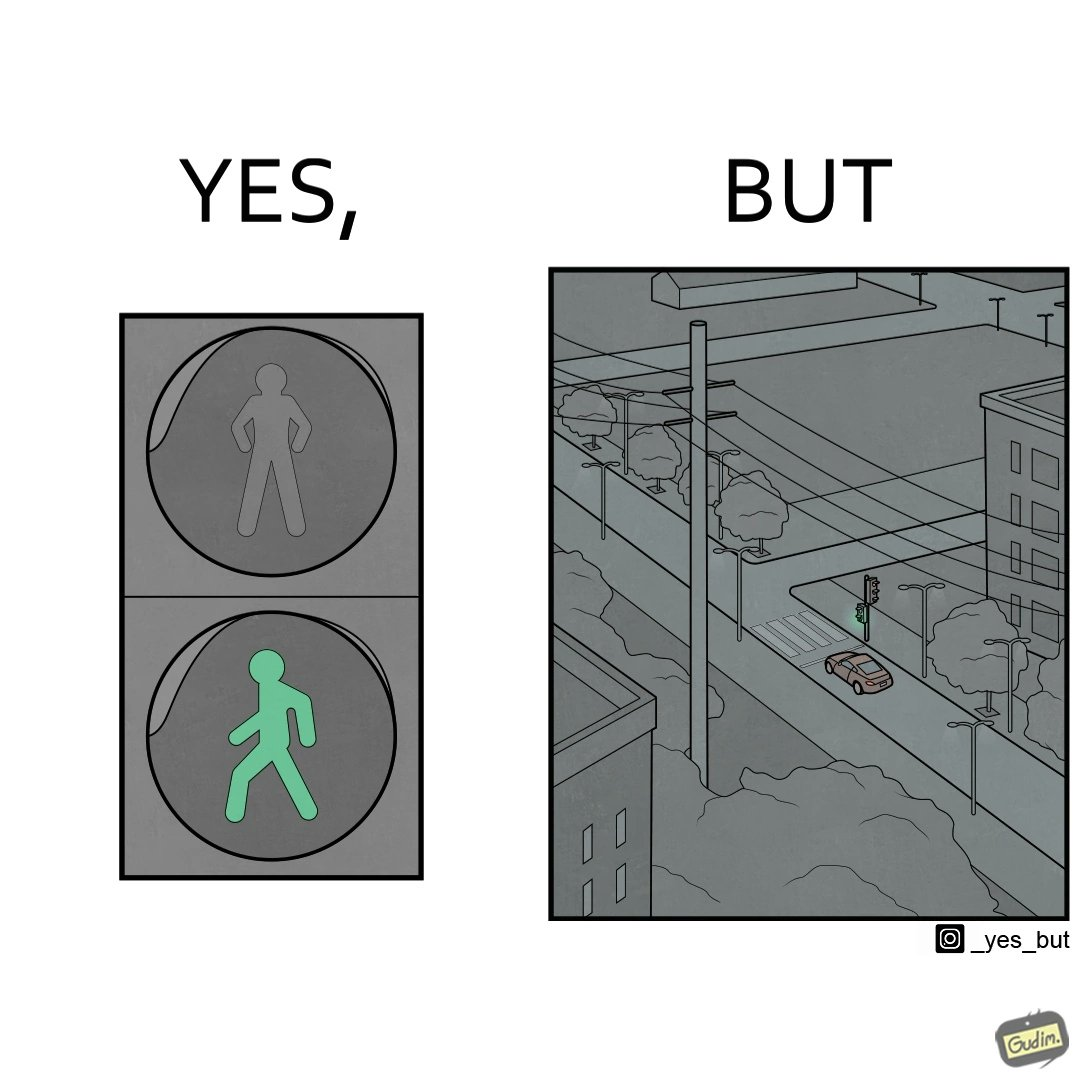Explain why this image is satirical. The image is funny because while walk signs are very useful for pedestrians to be able to cross roads safely, the become unnecessary and annoying for car drivers when these signals turn green even when there is no pedestrian tring to cross the road. 